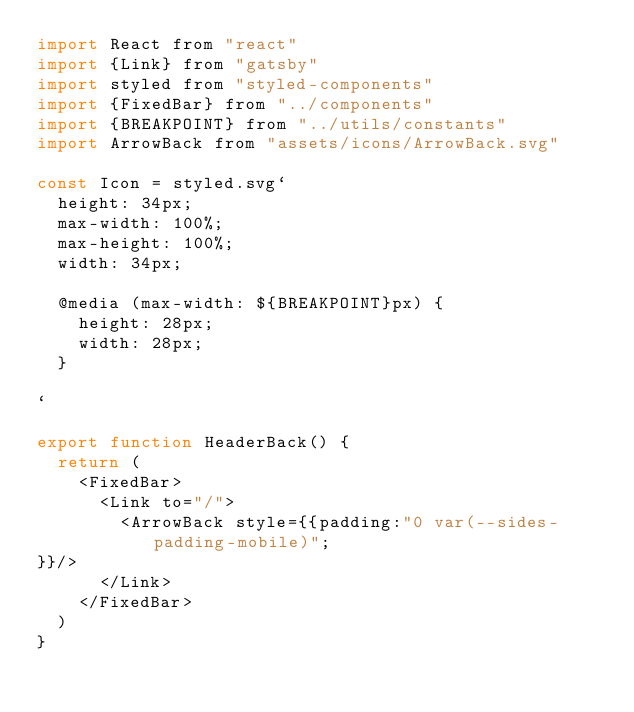Convert code to text. <code><loc_0><loc_0><loc_500><loc_500><_JavaScript_>import React from "react"
import {Link} from "gatsby"
import styled from "styled-components"
import {FixedBar} from "../components"
import {BREAKPOINT} from "../utils/constants"
import ArrowBack from "assets/icons/ArrowBack.svg"

const Icon = styled.svg`
  height: 34px;
  max-width: 100%;
  max-height: 100%;
  width: 34px;

  @media (max-width: ${BREAKPOINT}px) {
    height: 28px;
    width: 28px;
  }

`

export function HeaderBack() {
  return (
    <FixedBar>
      <Link to="/">
        <ArrowBack style={{padding:"0 var(--sides-padding-mobile)";
}}/>
      </Link>
    </FixedBar>
  )
}
</code> 